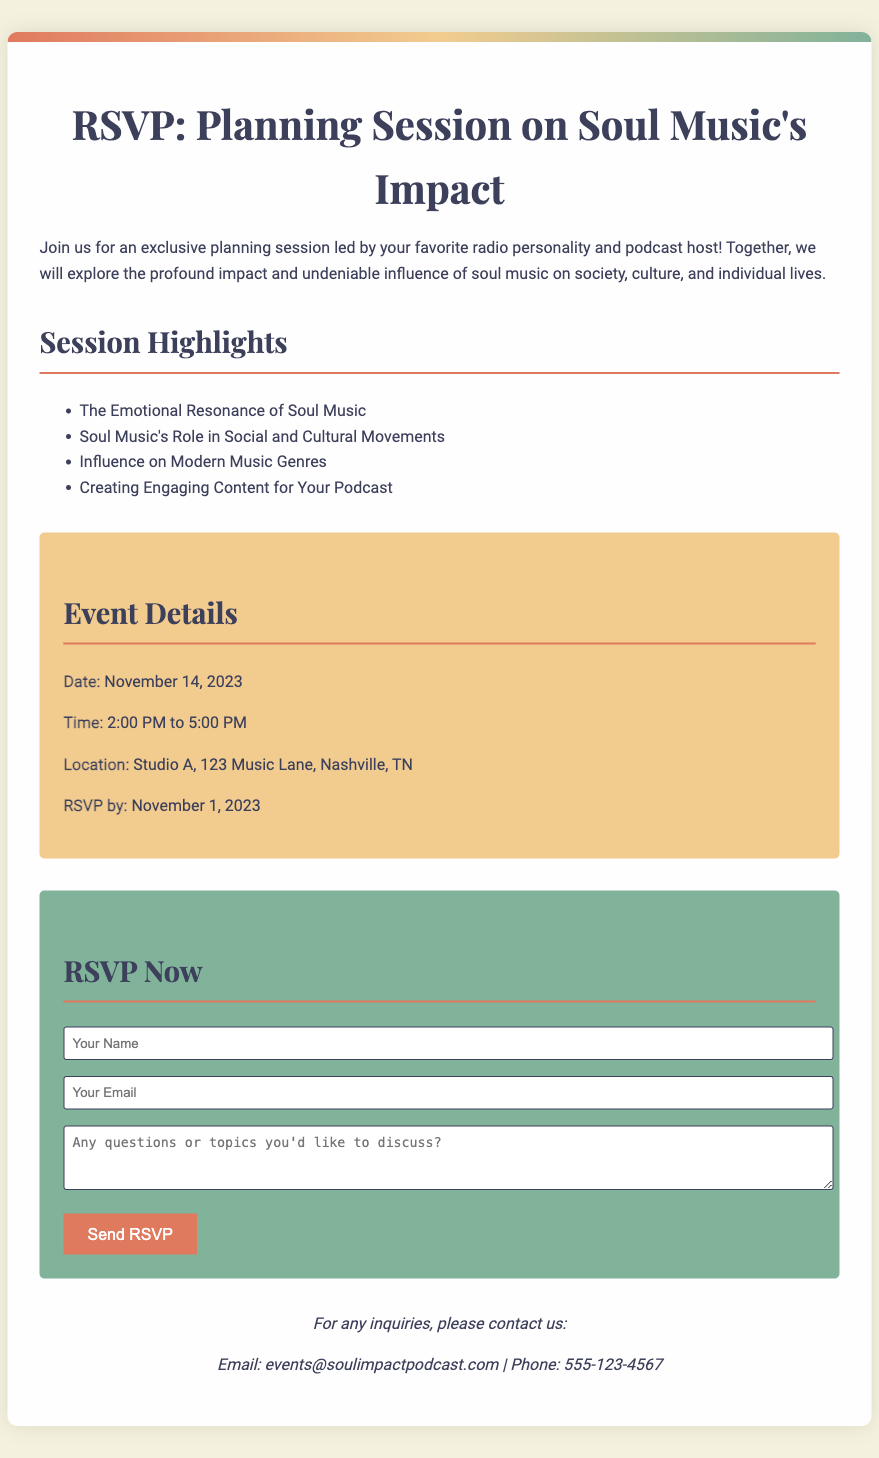What is the date of the event? The date of the event is specified directly in the document.
Answer: November 14, 2023 What is the location of the planning session? The location is detailed in the event details section of the document.
Answer: Studio A, 123 Music Lane, Nashville, TN What time does the event start? The start time is mentioned in the event details section.
Answer: 2:00 PM What is the deadline for RSVPs? The RSVP deadline is included in the event details.
Answer: November 1, 2023 How long is the planning session? The duration of the event is indicated by the start and end time.
Answer: 3 hours What topics will be covered in the session? The topics are listed in the highlights section of the document.
Answer: The Emotional Resonance of Soul Music What is the contact email for inquiries? The contact email is provided in the contact info section.
Answer: events@soulimpactpodcast.com How many highlights are listed for the session? The number of highlights can be counted directly in the document.
Answer: 4 What type of session is this document for? The primary purpose of the document is indicated at the top.
Answer: Planning Session 